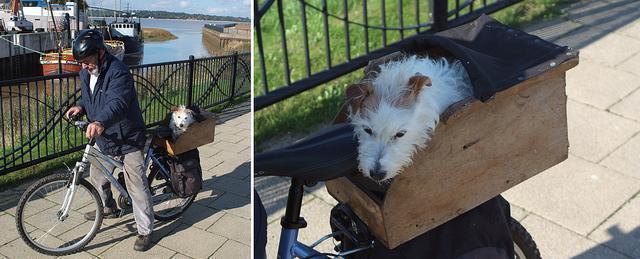Who placed this animal in the box?
Indicate the correct choice and explain in the format: 'Answer: answer
Rationale: rationale.'
Options: Hobo, dorothy, bike rider, wicked witch. Answer: bike rider.
Rationale: The dog belongs to the bike rider. 